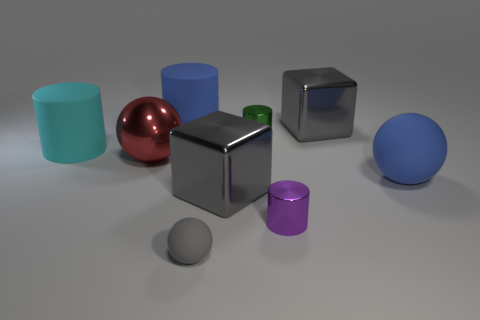There is a big matte object that is the same color as the large rubber sphere; what shape is it?
Provide a succinct answer. Cylinder. There is a cylinder that is the same color as the large rubber sphere; what is its size?
Provide a short and direct response. Large. There is a blue cylinder; are there any red balls behind it?
Provide a succinct answer. No. The purple shiny thing is what shape?
Your answer should be very brief. Cylinder. What shape is the large blue matte object to the right of the blue matte thing left of the large blue matte thing in front of the large blue cylinder?
Provide a succinct answer. Sphere. How many other things are there of the same shape as the small purple object?
Make the answer very short. 3. The cylinder that is behind the big gray shiny cube that is on the right side of the purple metallic cylinder is made of what material?
Your answer should be compact. Rubber. Are there any other things that are the same size as the red ball?
Your answer should be very brief. Yes. Is the material of the purple cylinder the same as the blue object that is on the left side of the green cylinder?
Your answer should be very brief. No. There is a thing that is both behind the red metal thing and right of the tiny purple thing; what is it made of?
Offer a terse response. Metal. 